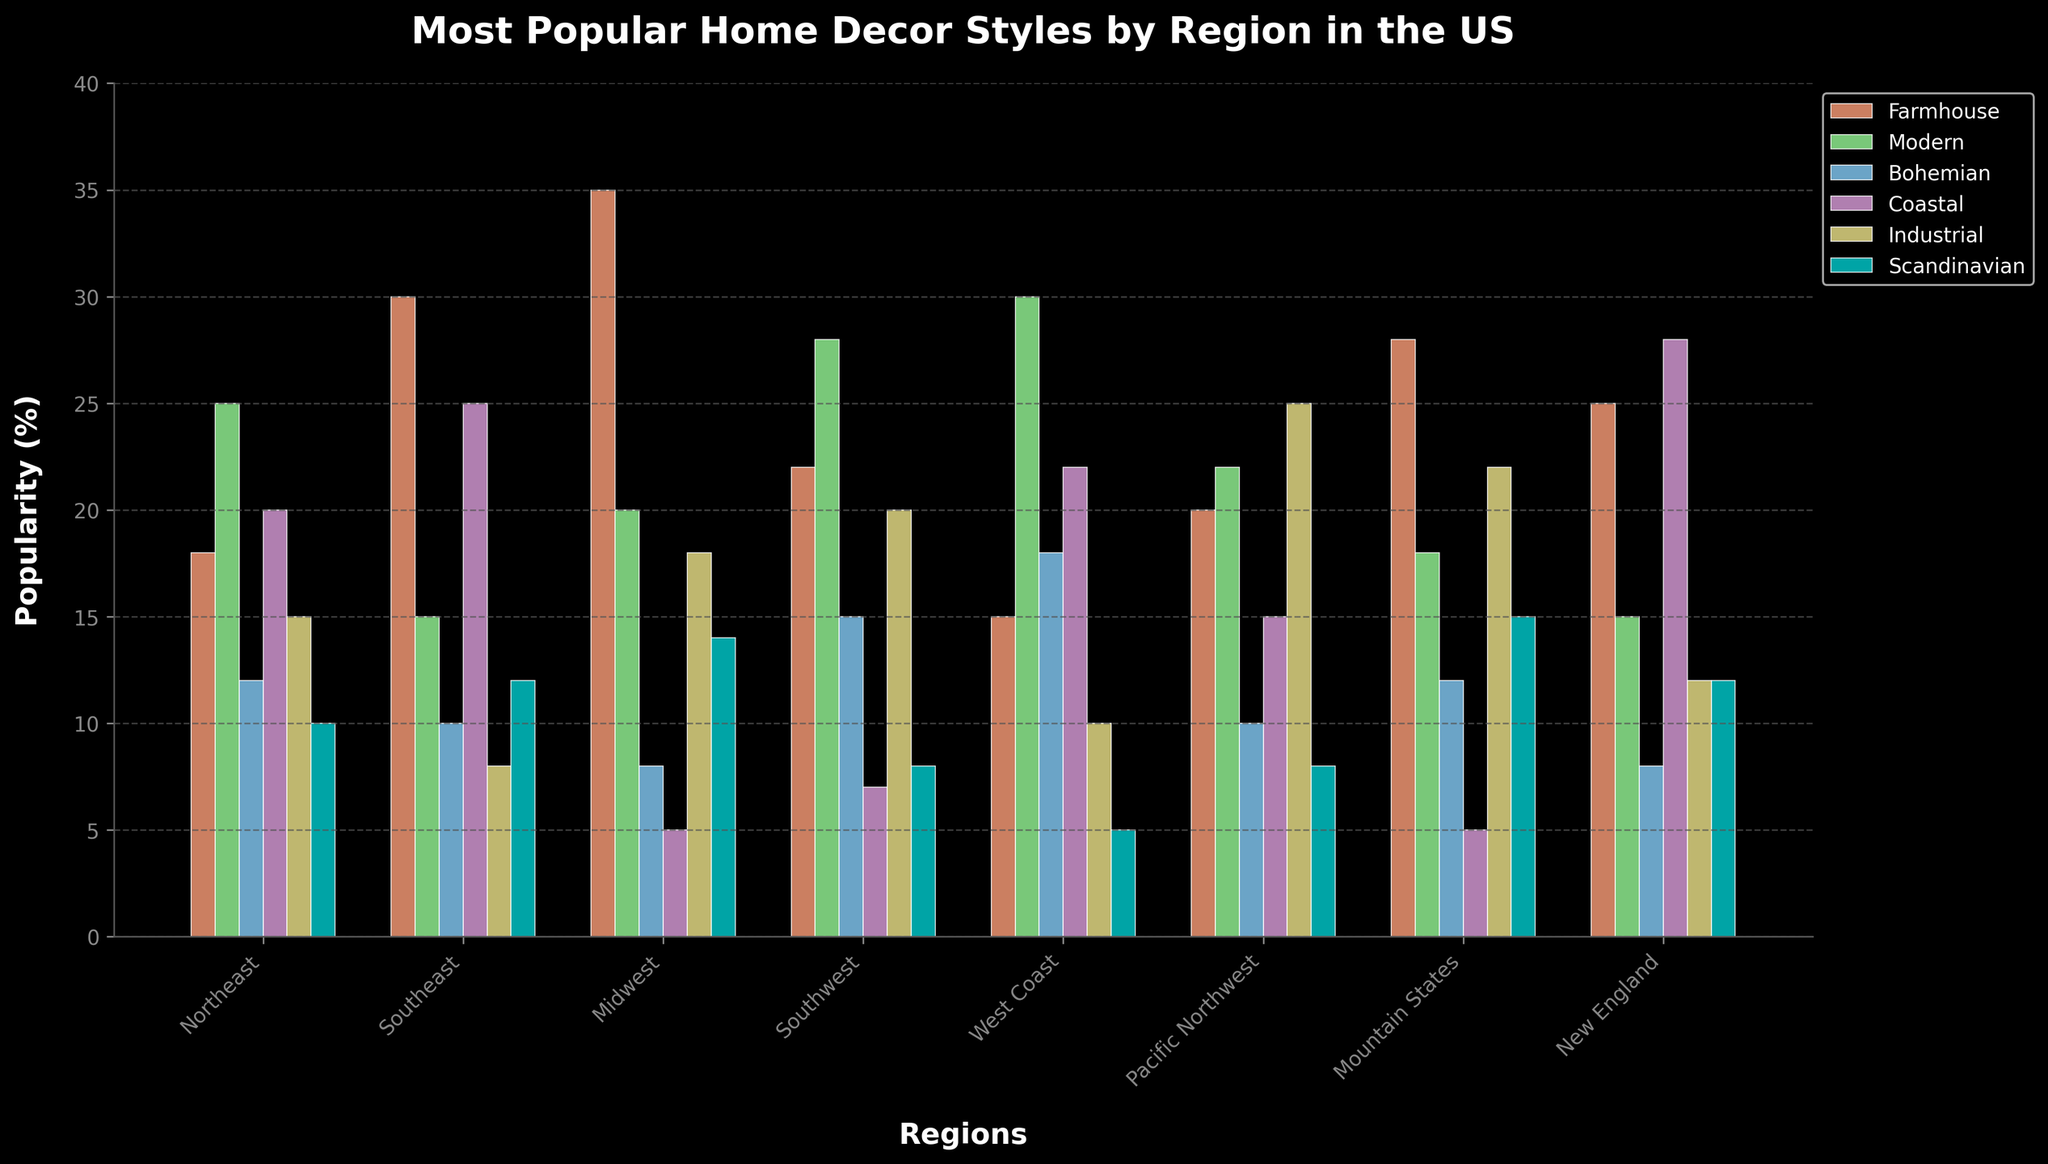Which region has the highest popularity for Farmhouse style? By observing the height of the bars representing the Farmhouse style, we can see that the Midwest has the highest bar at 35%.
Answer: Midwest Which home decor style is most popular in the West Coast region? Looking at the bars for the West Coast region, the highest bar is for the Modern style at 30%.
Answer: Modern What is the average popularity of the Coastal style across all regions? The Coastal values are 20, 25, 5, 7, 22, 15, 5, 28. Adding these gives us 127. There are 8 regions, so the average is 127 / 8 = 15.875.
Answer: 15.875 Compare the Industrial style popularity between the Mountain States and Pacific Northwest regions. Which region has higher popularity? The bar for Industrial in the Mountain States is at 22%, while in the Pacific Northwest it's at 25%. Thus, the Pacific Northwest region has higher popularity.
Answer: Pacific Northwest Which region has the lowest popularity for the Scandinavian style? The bars representing Scandinavian style show the smallest height in the West Coast region, which is 5%.
Answer: West Coast In which regions is the Coastal style more popular than the Bohemian style? By comparing the heights of the bars for Coastal and Bohemian styles across all regions, the regions where Coastal is more popular than Bohemian are Northeast, Southeast, New England, and West Coast.
Answer: Northeast, Southeast, New England, West Coast What is the total popularity percentage of the Modern style in the Northeast and West Coast regions combined? Adding the Modern values for the Northeast (25%) and West Coast (30%) regions, we get a total of 55%.
Answer: 55% Which style has the least variation in popularity across all regions? Observing the bars and checking the ranges of values, Scandinavian shows relatively low variation with values of 10, 12, 14, 8, 5, 8, 15, 12. The variation can be described by the range, which in this case is 15-5 = 10.
Answer: Scandinavian In which region is the Bohemian style more than 15% popular? By looking at the Bohemian bars, only the West Coast region shows Bohemian style popularity above 15% at 18%.
Answer: West Coast For the Southeast region, compare the combined popularity of the Farmhouse and Coastal styles against the combined popularity of the Modern and Bohemian styles. Which combination is higher? Adding Farmhouse (30%) and Coastal (25%) gives 55%, while Modern (15%) and Bohemian (10%) gives 25%. The combination of Farmhouse and Coastal styles is higher.
Answer: Farmhouse and Coastal 